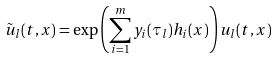Convert formula to latex. <formula><loc_0><loc_0><loc_500><loc_500>\tilde { u } _ { l } ( t , x ) = \exp \left ( \sum _ { i = 1 } ^ { m } y _ { i } ( \tau _ { l } ) h _ { i } ( x ) \right ) u _ { l } ( t , x )</formula> 